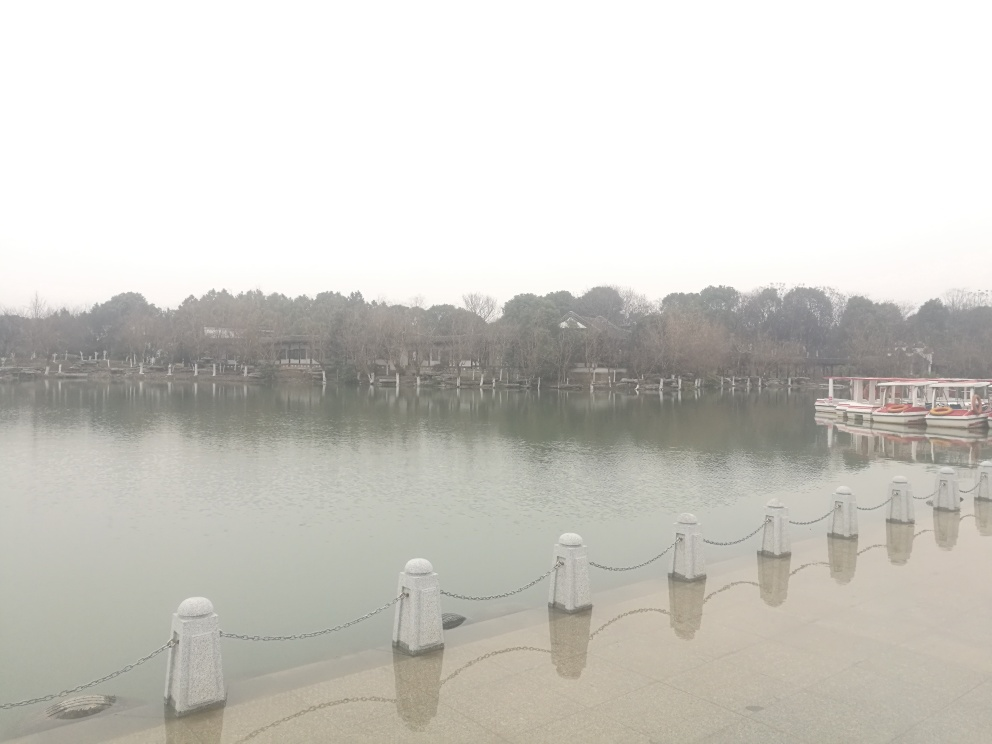Could you describe the mood conveyed by the image? The image exudes a tranquil and serene mood. The stillness of the water and the quiet, seemingly deserted area contribute to a sense of peacefulness. The muted colors and lack of activity amplify the feeling of calmness. 